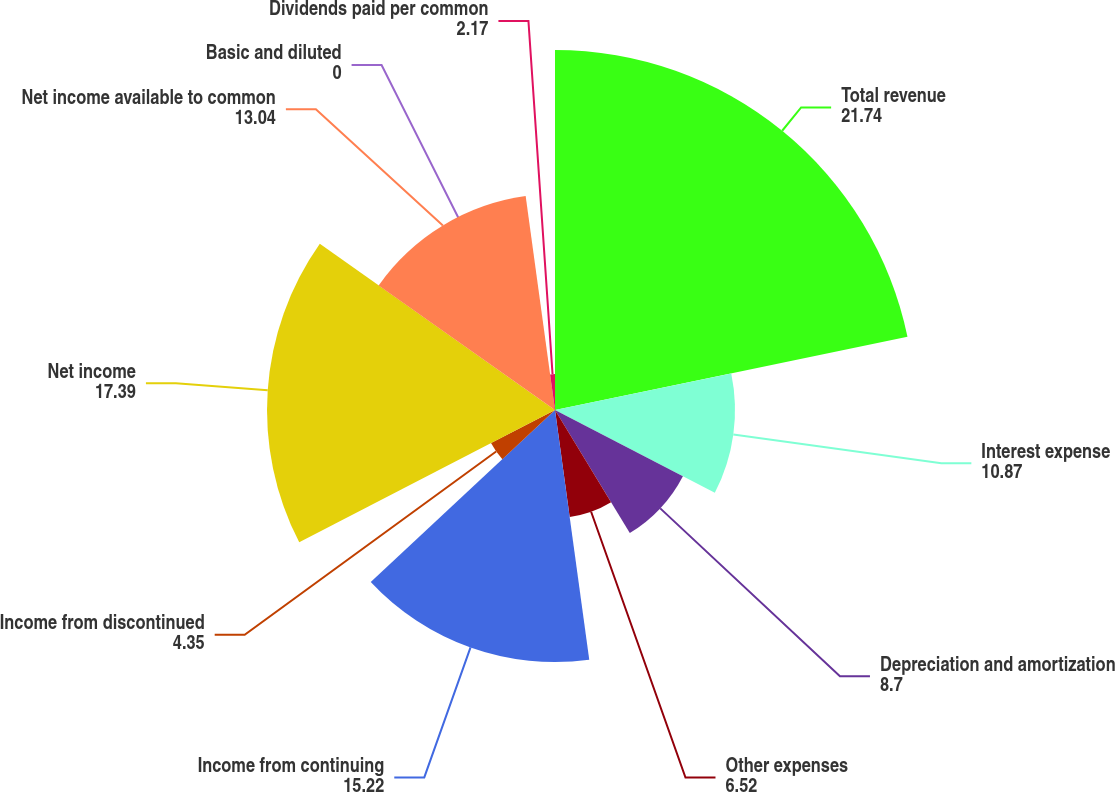Convert chart. <chart><loc_0><loc_0><loc_500><loc_500><pie_chart><fcel>Total revenue<fcel>Interest expense<fcel>Depreciation and amortization<fcel>Other expenses<fcel>Income from continuing<fcel>Income from discontinued<fcel>Net income<fcel>Net income available to common<fcel>Basic and diluted<fcel>Dividends paid per common<nl><fcel>21.74%<fcel>10.87%<fcel>8.7%<fcel>6.52%<fcel>15.22%<fcel>4.35%<fcel>17.39%<fcel>13.04%<fcel>0.0%<fcel>2.17%<nl></chart> 